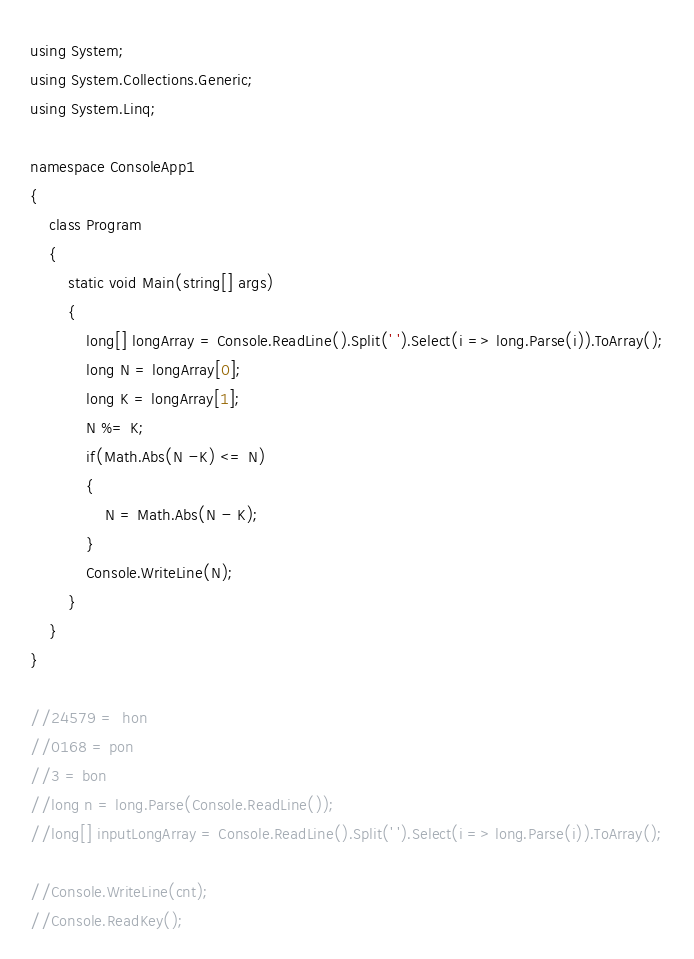<code> <loc_0><loc_0><loc_500><loc_500><_C#_>using System;
using System.Collections.Generic;
using System.Linq;

namespace ConsoleApp1
{
    class Program
    {
        static void Main(string[] args)
        {
            long[] longArray = Console.ReadLine().Split(' ').Select(i => long.Parse(i)).ToArray();
            long N = longArray[0];
            long K = longArray[1];
            N %= K;
            if(Math.Abs(N -K) <= N)
            {
                N = Math.Abs(N - K);
            }
            Console.WriteLine(N);
        }
    }
}

//24579 =  hon
//0168 = pon
//3 = bon
//long n = long.Parse(Console.ReadLine());
//long[] inputLongArray = Console.ReadLine().Split(' ').Select(i => long.Parse(i)).ToArray();

//Console.WriteLine(cnt);
//Console.ReadKey();
</code> 